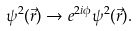<formula> <loc_0><loc_0><loc_500><loc_500>\psi ^ { 2 } ( \vec { r } ) \rightarrow e ^ { 2 i \phi } \psi ^ { 2 } ( \vec { r } ) .</formula> 